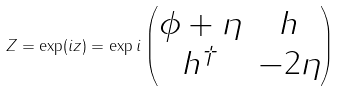<formula> <loc_0><loc_0><loc_500><loc_500>Z = \exp ( i z ) = \exp i \begin{pmatrix} \phi + \eta & h \\ h ^ { \dagger } & - 2 \eta \end{pmatrix}</formula> 